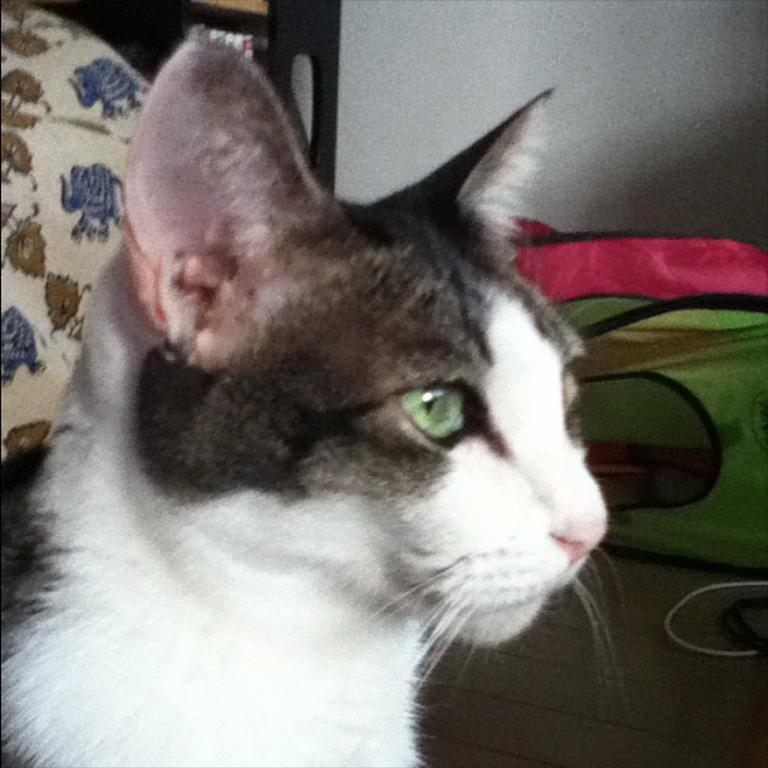What animal can be seen in the image? There is a cat in the image. In which direction is the cat looking? The cat is looking to the right side. What can be seen in the background of the image? There are clothes and a wall in the background of the image. What type of object is at the top of the image? There is a wooden object at the top of the image. What type of wool can be seen in the image? There is no wool present in the image. How many drops of glue are visible on the cat in the image? There are no drops of glue visible on the cat in the image. 